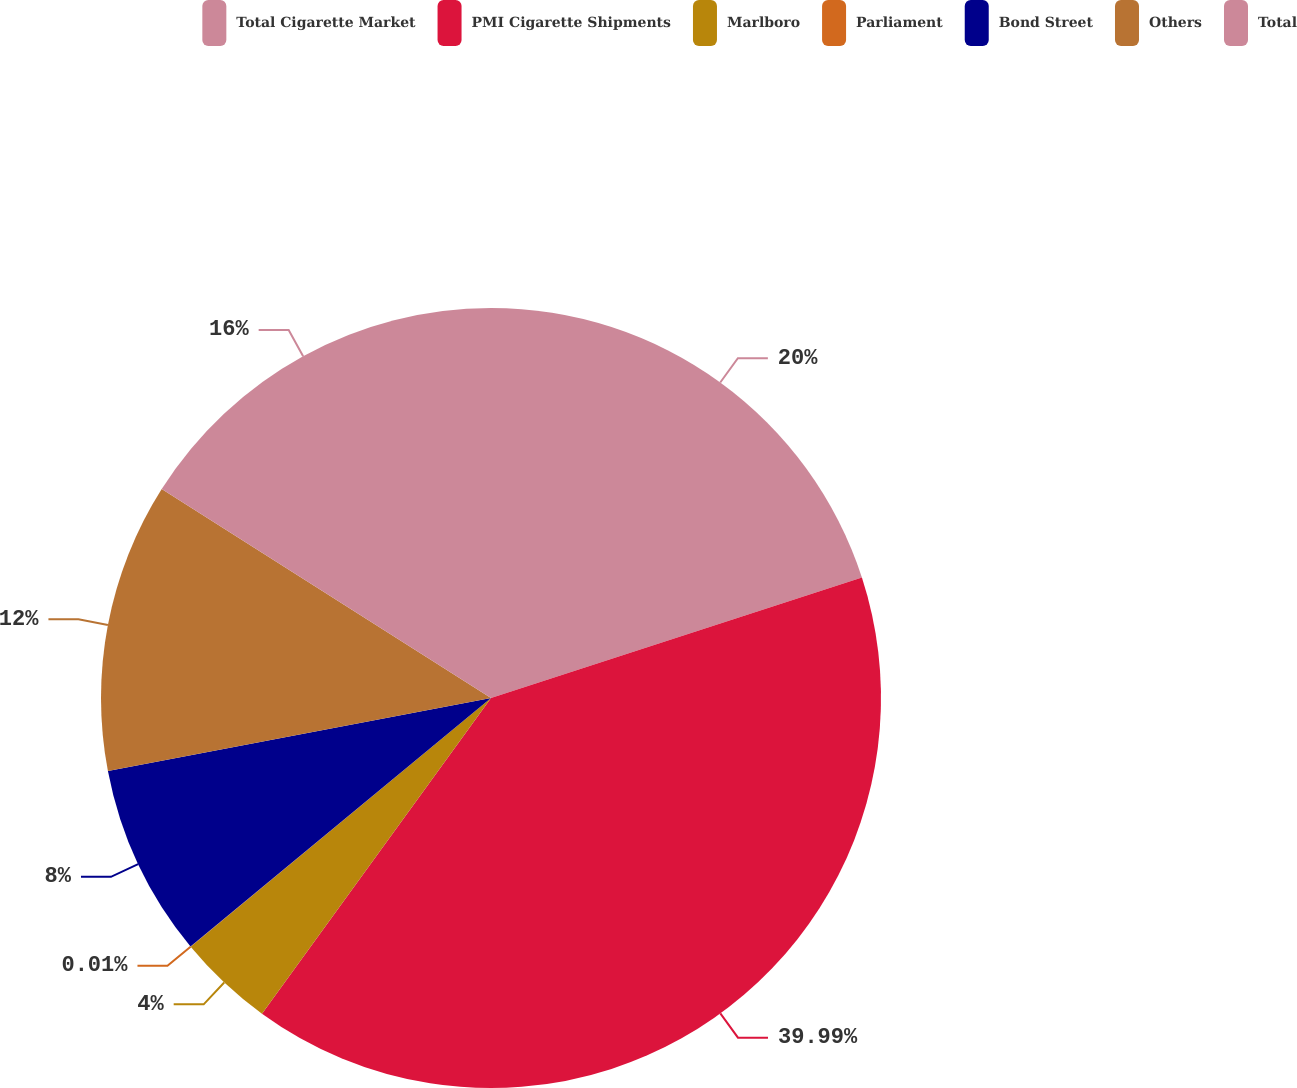Convert chart to OTSL. <chart><loc_0><loc_0><loc_500><loc_500><pie_chart><fcel>Total Cigarette Market<fcel>PMI Cigarette Shipments<fcel>Marlboro<fcel>Parliament<fcel>Bond Street<fcel>Others<fcel>Total<nl><fcel>20.0%<fcel>39.99%<fcel>4.0%<fcel>0.01%<fcel>8.0%<fcel>12.0%<fcel>16.0%<nl></chart> 